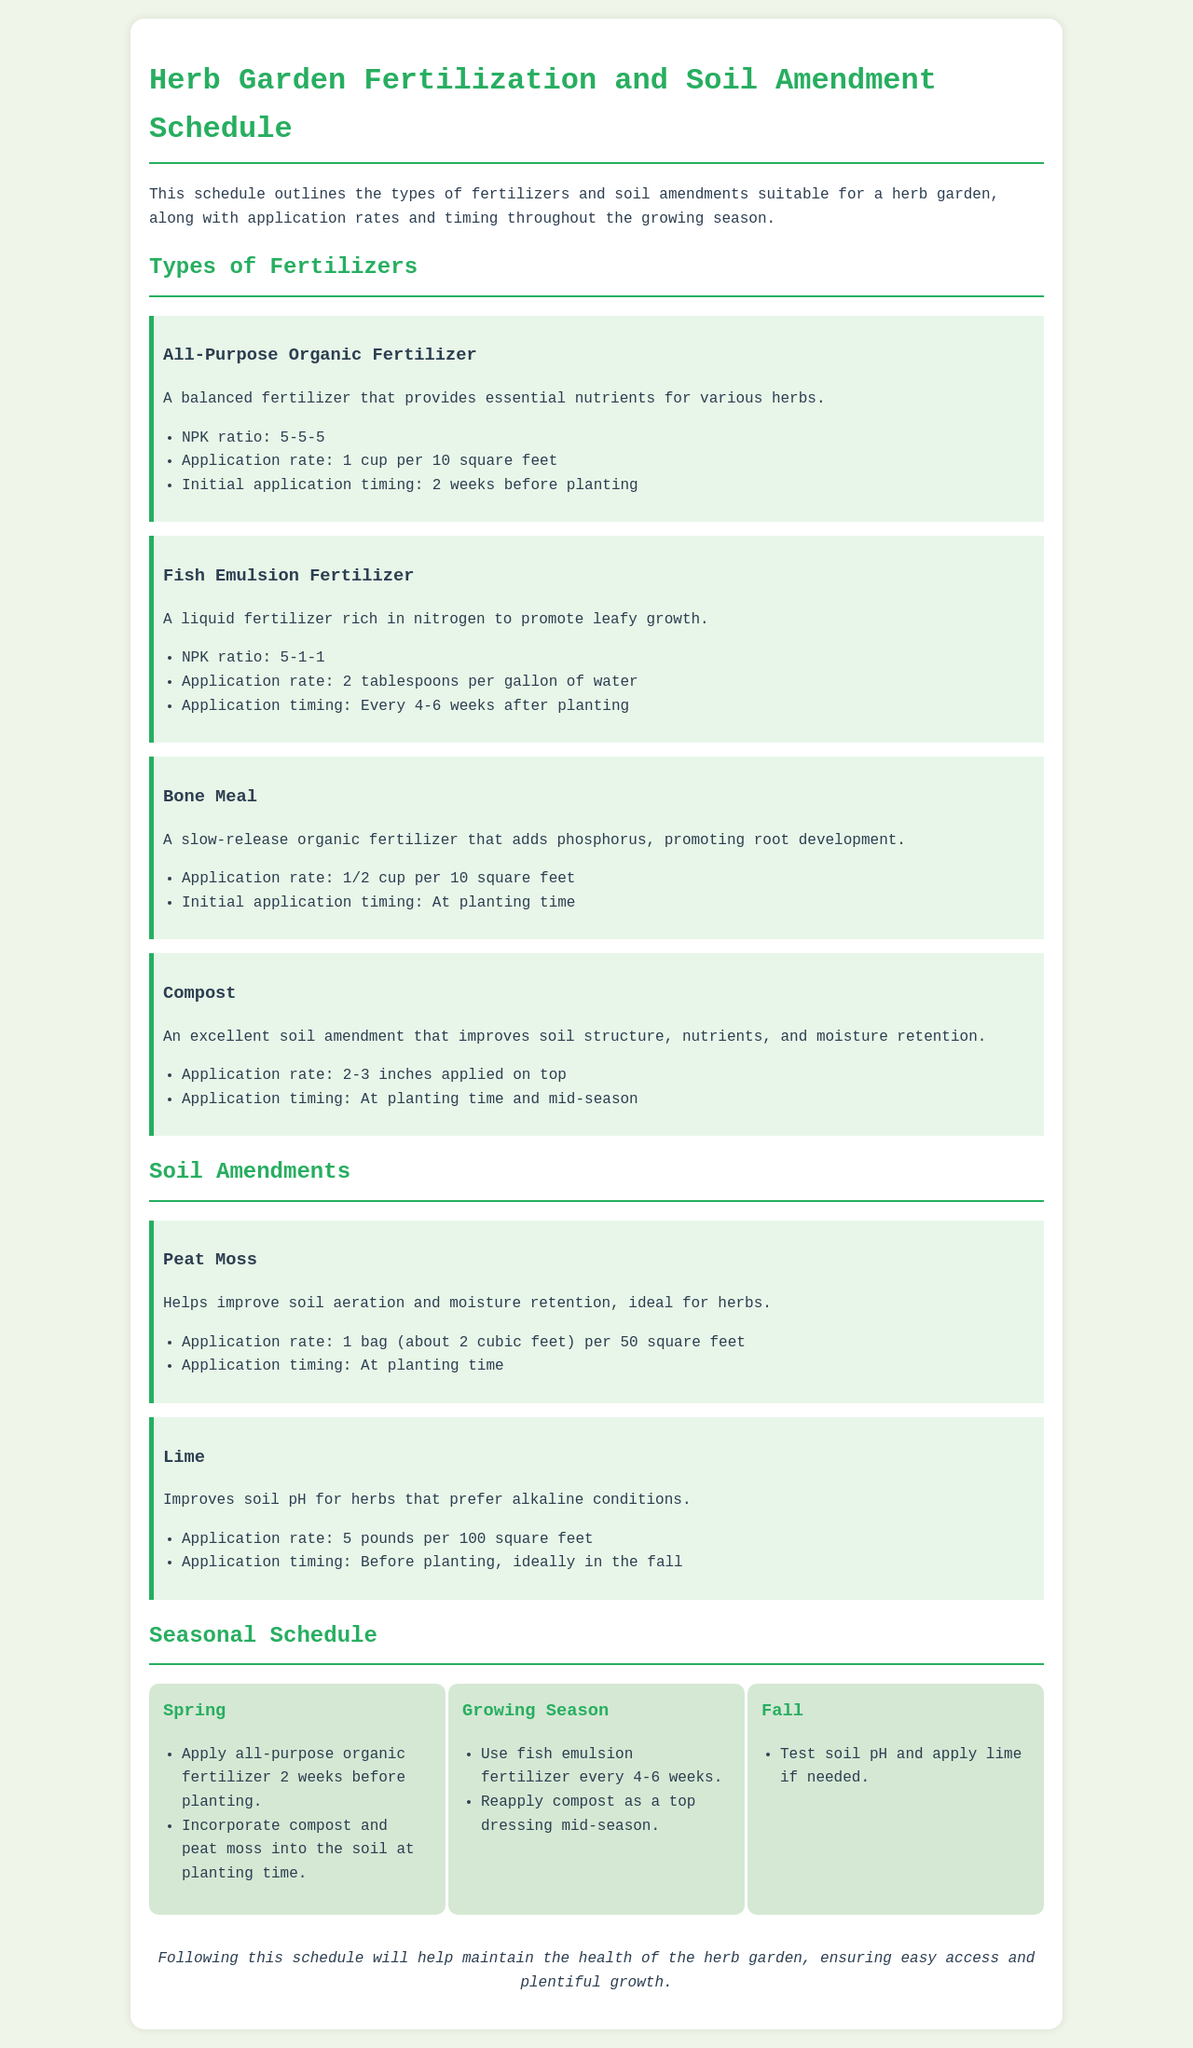what is the application rate of all-purpose organic fertilizer? The application rate for all-purpose organic fertilizer is specified in the document as 1 cup per 10 square feet.
Answer: 1 cup per 10 square feet when should fish emulsion fertilizer be applied? The document states that fish emulsion fertilizer should be applied every 4-6 weeks after planting.
Answer: Every 4-6 weeks after planting what is the NPK ratio of bone meal? The NPK ratio of bone meal is not provided, but it falls under specific characteristics mentioned in the schedule.
Answer: Not specified how many pounds of lime should be applied per 100 square feet? The application rate for lime, as stated in the document, is 5 pounds per 100 square feet.
Answer: 5 pounds per 100 square feet which amendment improves soil aeration? Peat moss is mentioned in the document as the amendment that helps improve soil aeration and moisture retention.
Answer: Peat moss what is the initial application timing for compost? The document specifies that compost should be applied at planting time and mid-season.
Answer: At planting time and mid-season when should the all-purpose organic fertilizer be applied? According to the document, all-purpose organic fertilizer should be applied 2 weeks before planting.
Answer: 2 weeks before planting what is added by bone meal? The document notes that bone meal adds phosphorus, promoting root development.
Answer: Phosphorus 